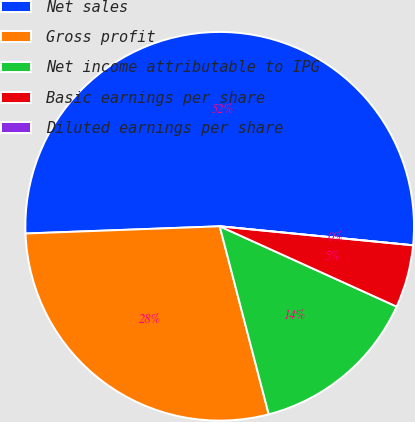Convert chart to OTSL. <chart><loc_0><loc_0><loc_500><loc_500><pie_chart><fcel>Net sales<fcel>Gross profit<fcel>Net income attributable to IPG<fcel>Basic earnings per share<fcel>Diluted earnings per share<nl><fcel>52.16%<fcel>28.47%<fcel>14.16%<fcel>5.22%<fcel>0.0%<nl></chart> 